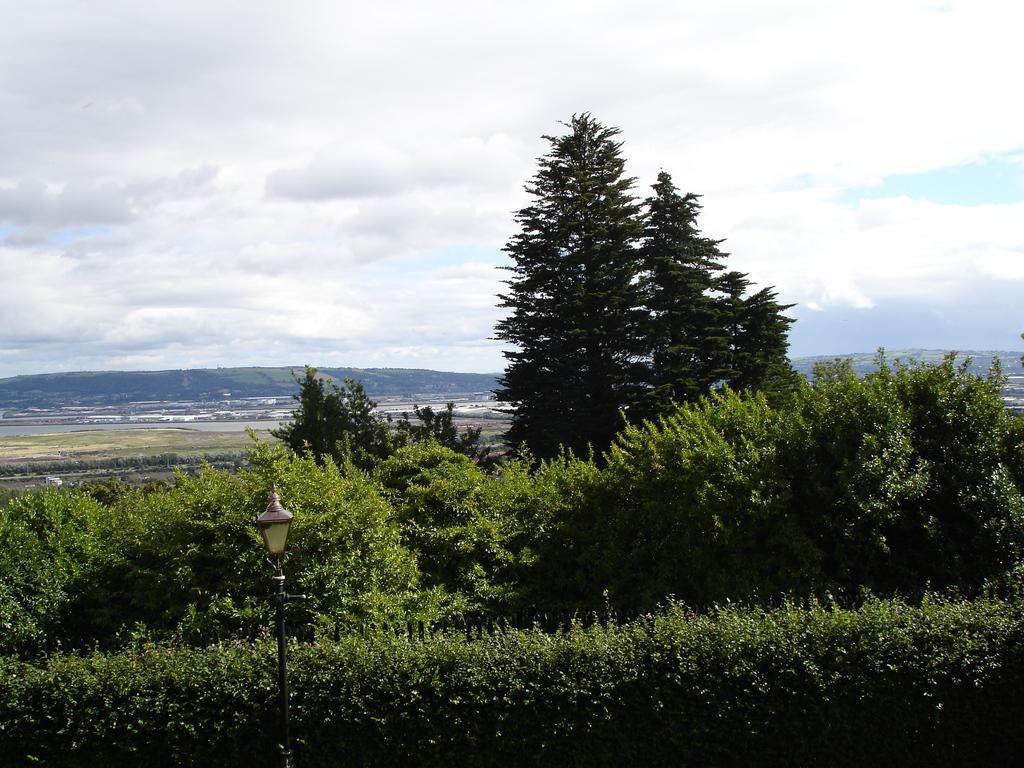What type of vegetation can be seen in the image? There are trees and plants in the image. What structure is present in the image? There is a light pole in the image. What can be seen in the background of the image? There are hills in the background of the image. What is visible in the sky at the top of the image? There are clouds visible in the sky at the top of the image. What type of seat can be seen in the image? There is no seat present in the image. How many bites of the plant can be seen in the image? There are no bites visible in the image, as plants do not have the ability to be bitten. 